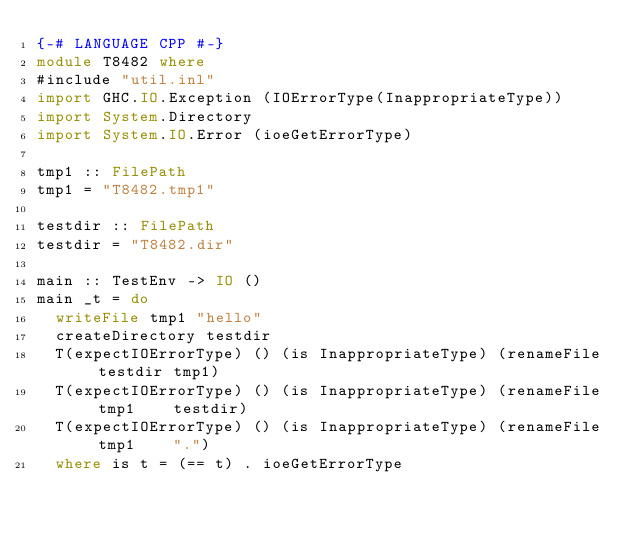<code> <loc_0><loc_0><loc_500><loc_500><_Haskell_>{-# LANGUAGE CPP #-}
module T8482 where
#include "util.inl"
import GHC.IO.Exception (IOErrorType(InappropriateType))
import System.Directory
import System.IO.Error (ioeGetErrorType)

tmp1 :: FilePath
tmp1 = "T8482.tmp1"

testdir :: FilePath
testdir = "T8482.dir"

main :: TestEnv -> IO ()
main _t = do
  writeFile tmp1 "hello"
  createDirectory testdir
  T(expectIOErrorType) () (is InappropriateType) (renameFile testdir tmp1)
  T(expectIOErrorType) () (is InappropriateType) (renameFile tmp1    testdir)
  T(expectIOErrorType) () (is InappropriateType) (renameFile tmp1    ".")
  where is t = (== t) . ioeGetErrorType
</code> 